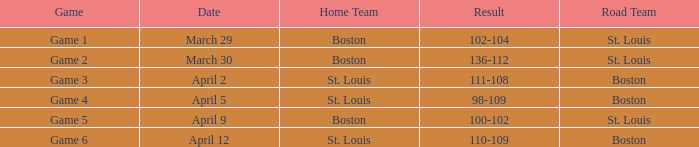What is the Result of the Game on April 9? 100-102. 